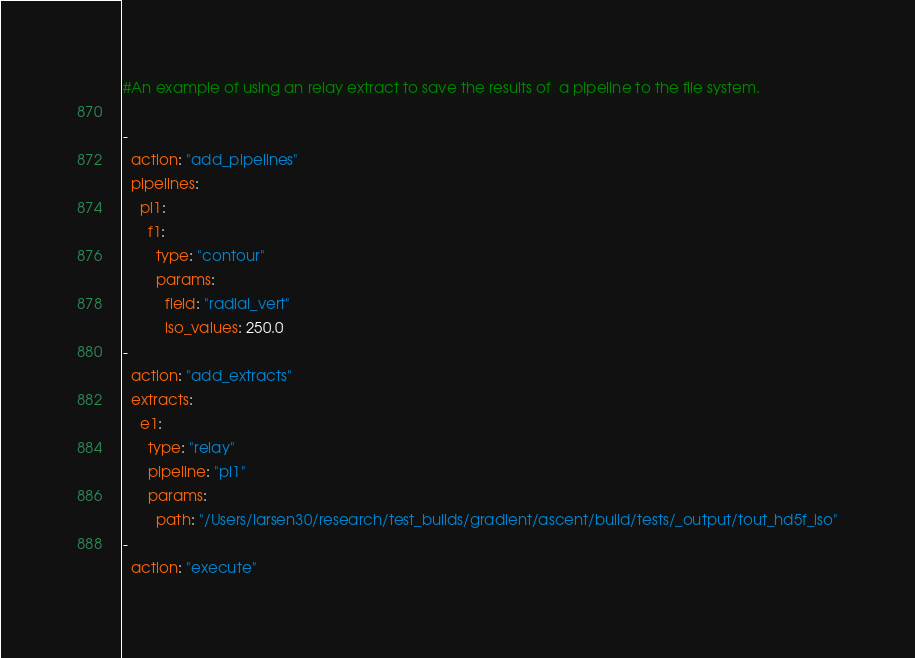<code> <loc_0><loc_0><loc_500><loc_500><_YAML_>#An example of using an relay extract to save the results of  a pipeline to the file system.

- 
  action: "add_pipelines"
  pipelines: 
    pl1: 
      f1: 
        type: "contour"
        params: 
          field: "radial_vert"
          iso_values: 250.0
- 
  action: "add_extracts"
  extracts: 
    e1: 
      type: "relay"
      pipeline: "pl1"
      params: 
        path: "/Users/larsen30/research/test_builds/gradient/ascent/build/tests/_output/tout_hd5f_iso"
- 
  action: "execute"
</code> 